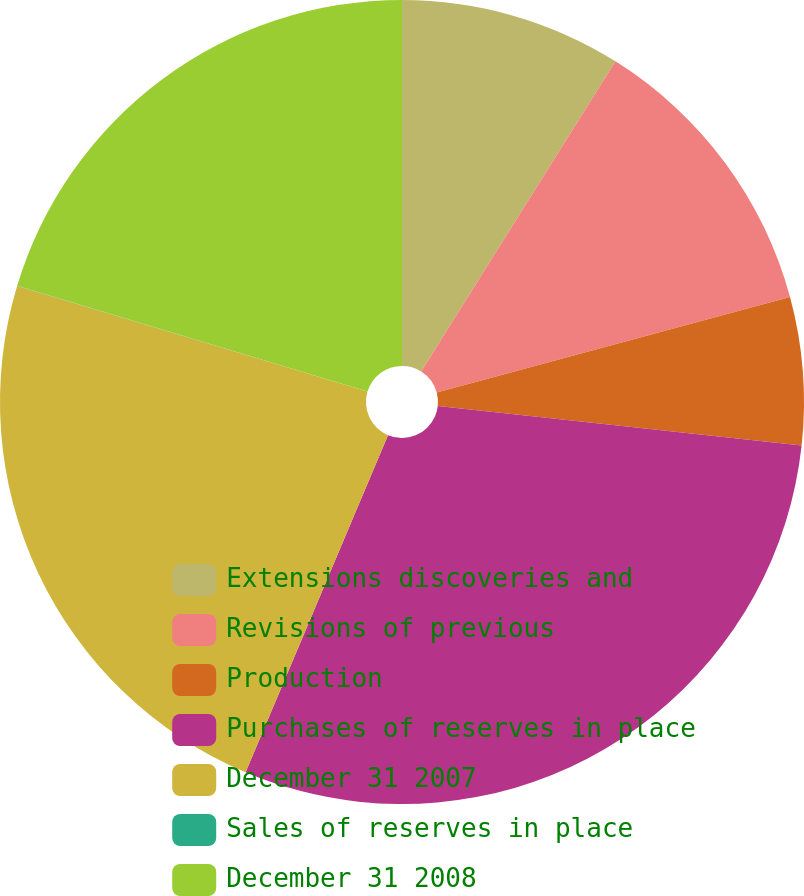Convert chart. <chart><loc_0><loc_0><loc_500><loc_500><pie_chart><fcel>Extensions discoveries and<fcel>Revisions of previous<fcel>Production<fcel>Purchases of reserves in place<fcel>December 31 2007<fcel>Sales of reserves in place<fcel>December 31 2008<nl><fcel>8.91%<fcel>11.88%<fcel>5.94%<fcel>29.63%<fcel>23.3%<fcel>0.01%<fcel>20.33%<nl></chart> 